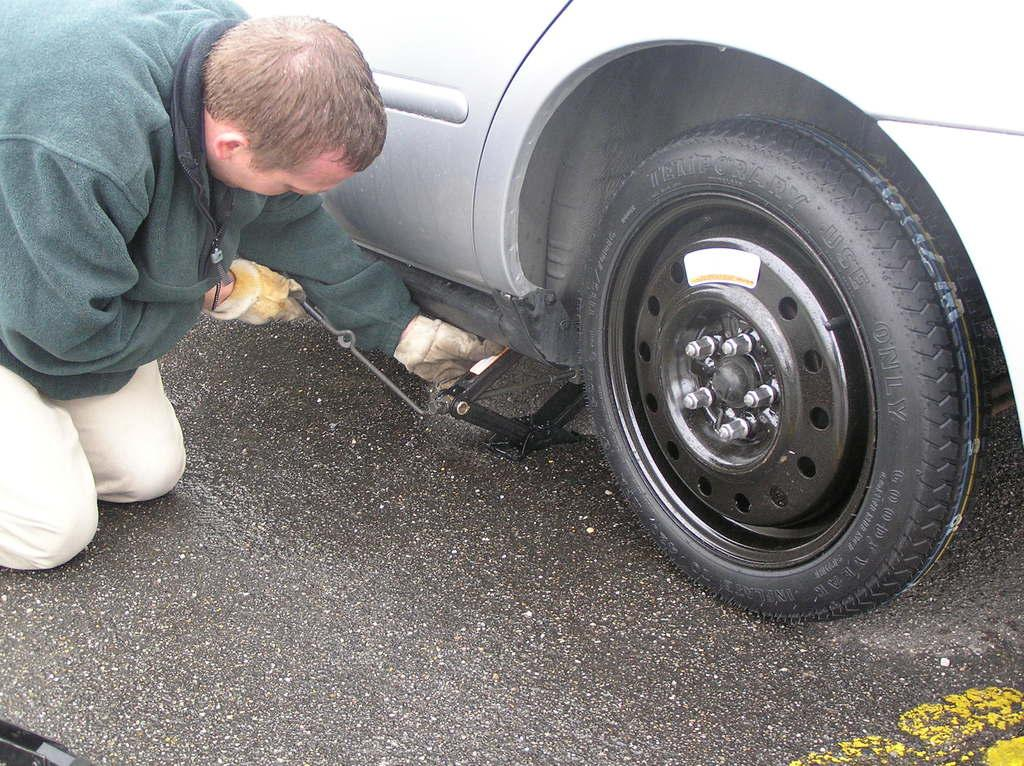What is the main subject of the image? There is a person in the image. What is the person doing in the image? The person is kneeling down on the road and trying to lift a car using a car gauge. What type of surface is the person on in the image? The image shows a road. What type of coat is the person wearing in the image? There is no coat visible in the image; the person is wearing regular clothing. What type of selection process is the person participating in while trying to lift the car? There is no selection process present in the image; the person is simply attempting to lift the car using a car gauge. 